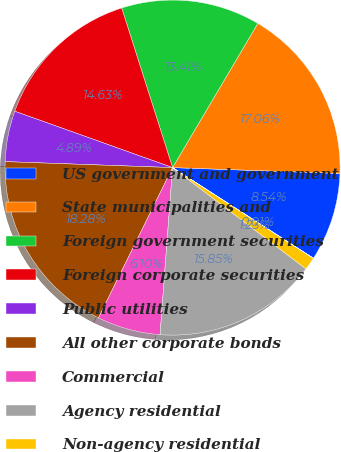Convert chart. <chart><loc_0><loc_0><loc_500><loc_500><pie_chart><fcel>US government and government<fcel>State municipalities and<fcel>Foreign government securities<fcel>Foreign corporate securities<fcel>Public utilities<fcel>All other corporate bonds<fcel>Commercial<fcel>Agency residential<fcel>Non-agency residential<fcel>Redeemable preferred stock<nl><fcel>8.54%<fcel>17.06%<fcel>13.41%<fcel>14.63%<fcel>4.89%<fcel>18.28%<fcel>6.1%<fcel>15.85%<fcel>1.23%<fcel>0.01%<nl></chart> 